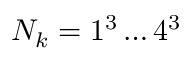<formula> <loc_0><loc_0><loc_500><loc_500>N _ { k } = 1 ^ { 3 } \dots 4 ^ { 3 }</formula> 